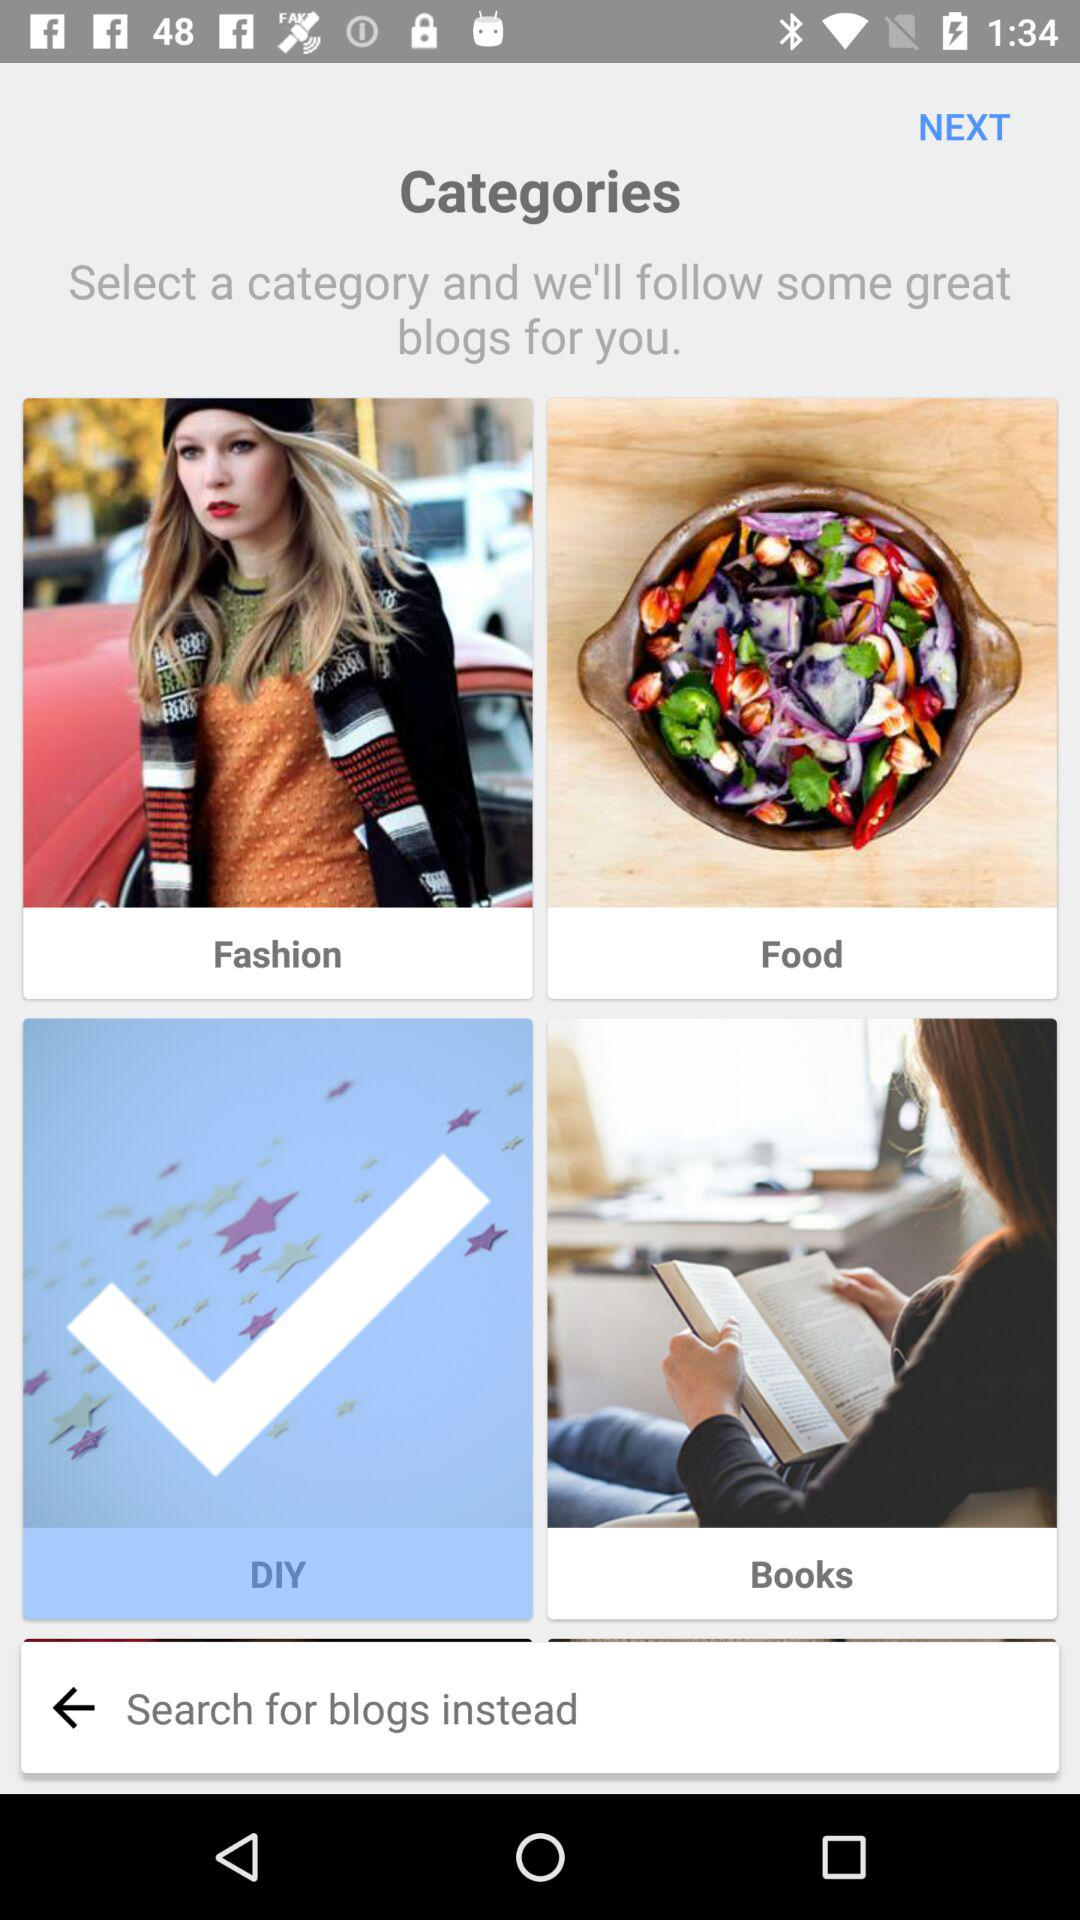How many categories are there in total?
Answer the question using a single word or phrase. 4 